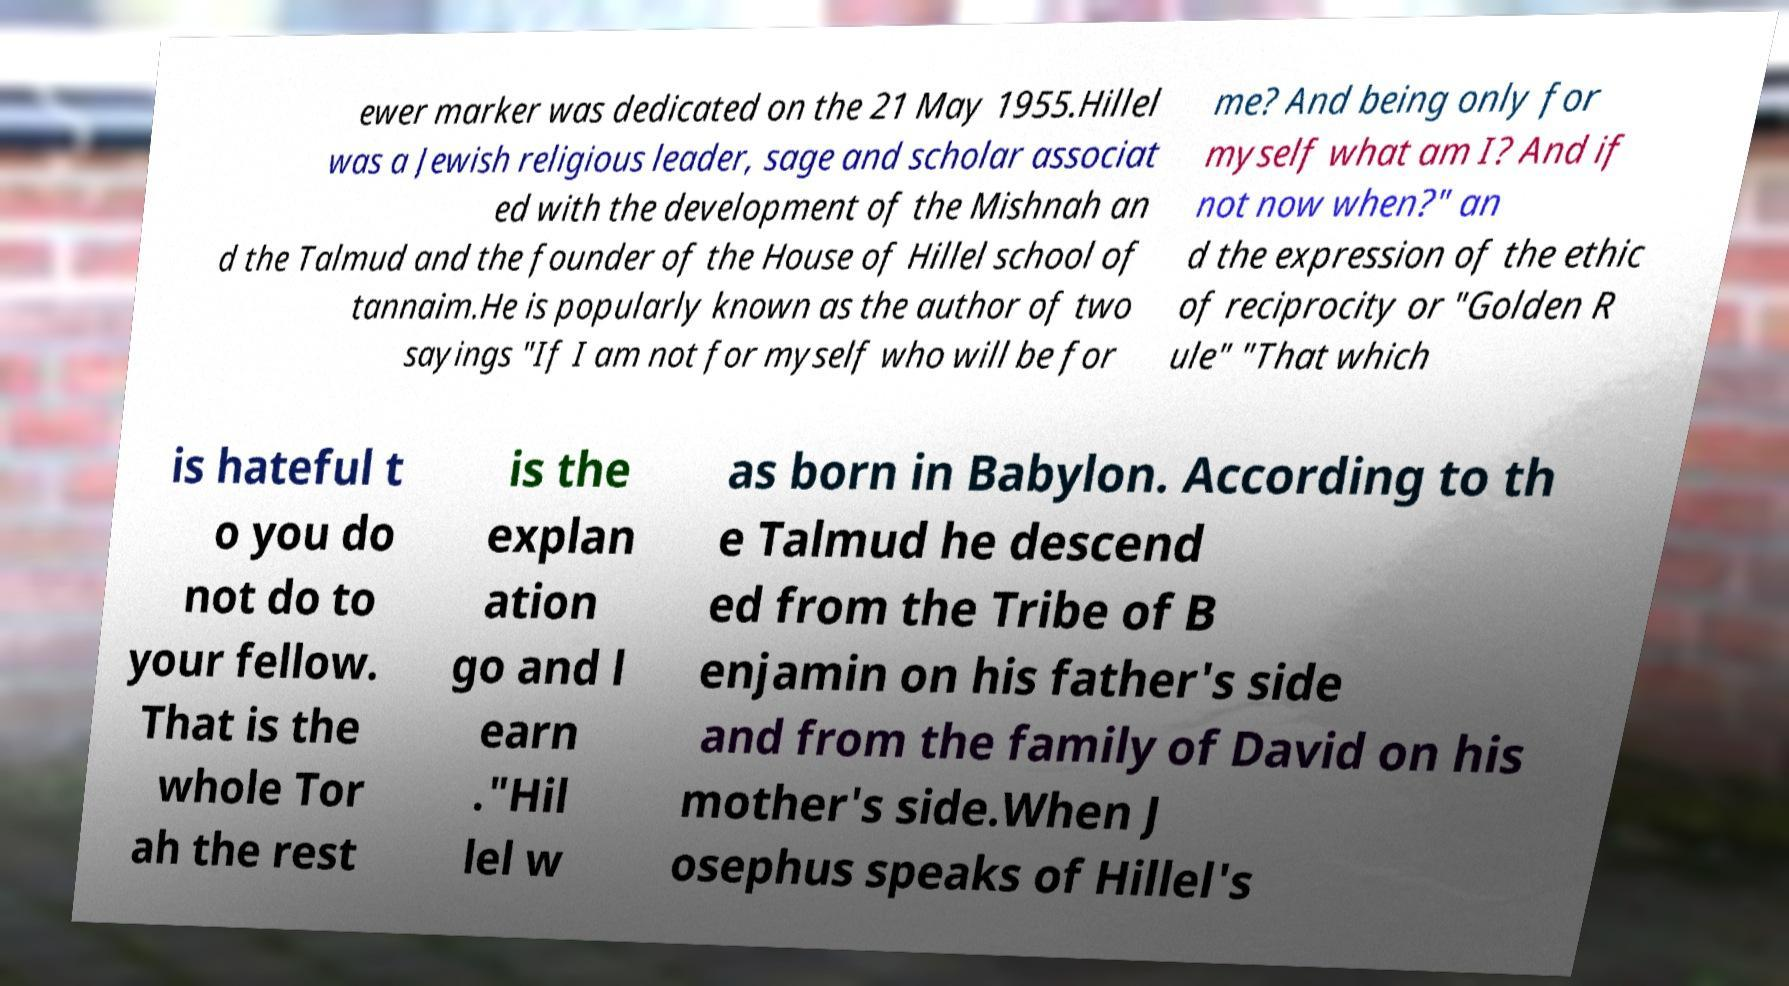Please read and relay the text visible in this image. What does it say? ewer marker was dedicated on the 21 May 1955.Hillel was a Jewish religious leader, sage and scholar associat ed with the development of the Mishnah an d the Talmud and the founder of the House of Hillel school of tannaim.He is popularly known as the author of two sayings "If I am not for myself who will be for me? And being only for myself what am I? And if not now when?" an d the expression of the ethic of reciprocity or "Golden R ule" "That which is hateful t o you do not do to your fellow. That is the whole Tor ah the rest is the explan ation go and l earn ."Hil lel w as born in Babylon. According to th e Talmud he descend ed from the Tribe of B enjamin on his father's side and from the family of David on his mother's side.When J osephus speaks of Hillel's 